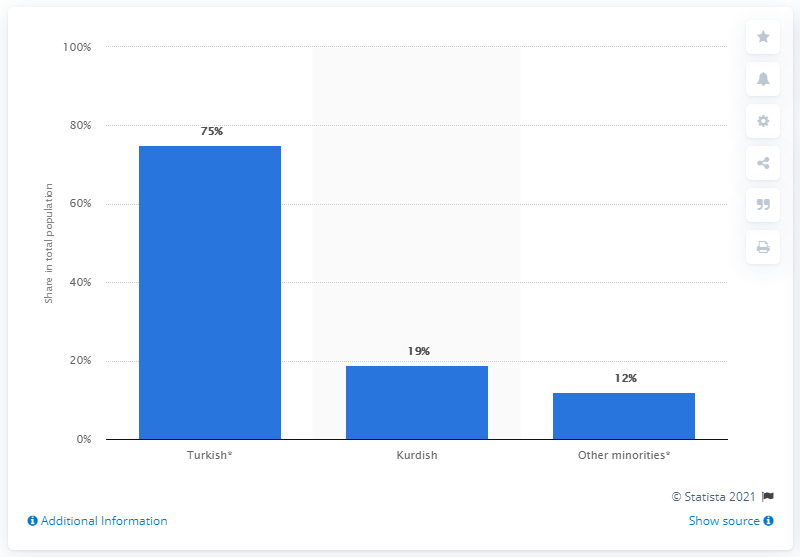Specify some key components in this picture. In 2016, Kurdish ethnicity made up 19 percent of Turkey's population. 